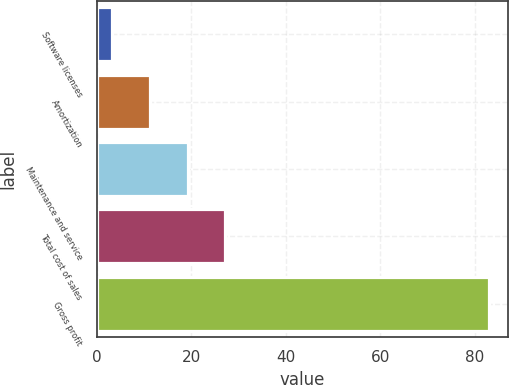<chart> <loc_0><loc_0><loc_500><loc_500><bar_chart><fcel>Software licenses<fcel>Amortization<fcel>Maintenance and service<fcel>Total cost of sales<fcel>Gross profit<nl><fcel>3.3<fcel>11.27<fcel>19.24<fcel>27.21<fcel>83<nl></chart> 